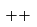<formula> <loc_0><loc_0><loc_500><loc_500>+ { + }</formula> 